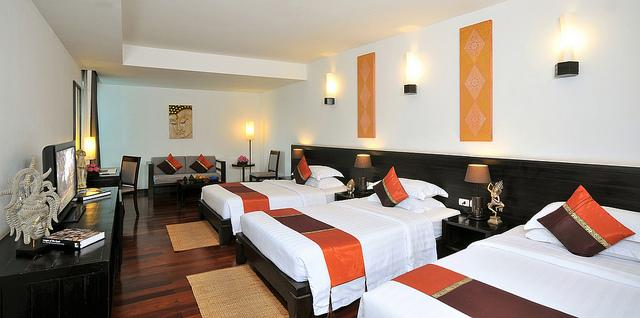In what continent is this hotel likely to be located? Please explain your reasoning. asia. The continent is asia. 